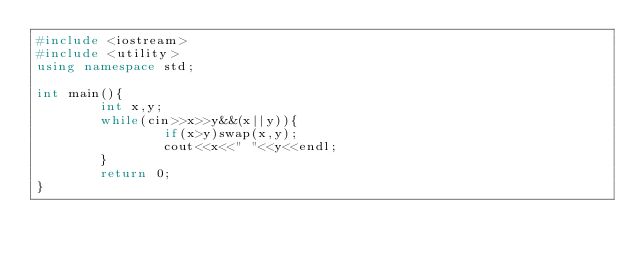<code> <loc_0><loc_0><loc_500><loc_500><_C++_>#include <iostream>
#include <utility>
using namespace std;

int main(){
        int x,y;
        while(cin>>x>>y&&(x||y)){
                if(x>y)swap(x,y);
                cout<<x<<" "<<y<<endl;
        }
        return 0;
}</code> 